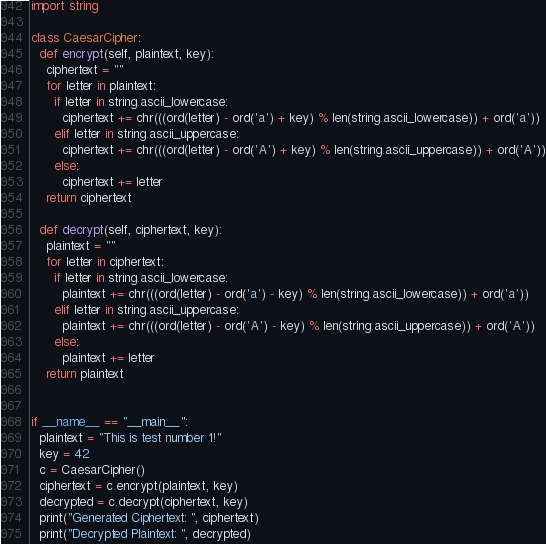<code> <loc_0><loc_0><loc_500><loc_500><_Python_>import string

class CaesarCipher:
  def encrypt(self, plaintext, key):
    ciphertext = ""
    for letter in plaintext:
      if letter in string.ascii_lowercase:
        ciphertext += chr(((ord(letter) - ord('a') + key) % len(string.ascii_lowercase)) + ord('a'))
      elif letter in string.ascii_uppercase:
        ciphertext += chr(((ord(letter) - ord('A') + key) % len(string.ascii_uppercase)) + ord('A'))
      else:
        ciphertext += letter
    return ciphertext

  def decrypt(self, ciphertext, key):
    plaintext = ""
    for letter in ciphertext:
      if letter in string.ascii_lowercase:
        plaintext += chr(((ord(letter) - ord('a') - key) % len(string.ascii_lowercase)) + ord('a'))
      elif letter in string.ascii_uppercase:
        plaintext += chr(((ord(letter) - ord('A') - key) % len(string.ascii_uppercase)) + ord('A'))
      else:
        plaintext += letter
    return plaintext


if __name__ == "__main__":
  plaintext = "This is test number 1!"
  key = 42
  c = CaesarCipher()
  ciphertext = c.encrypt(plaintext, key)
  decrypted = c.decrypt(ciphertext, key)
  print("Generated Ciphertext: ", ciphertext)
  print("Decrypted Plaintext: ", decrypted)</code> 